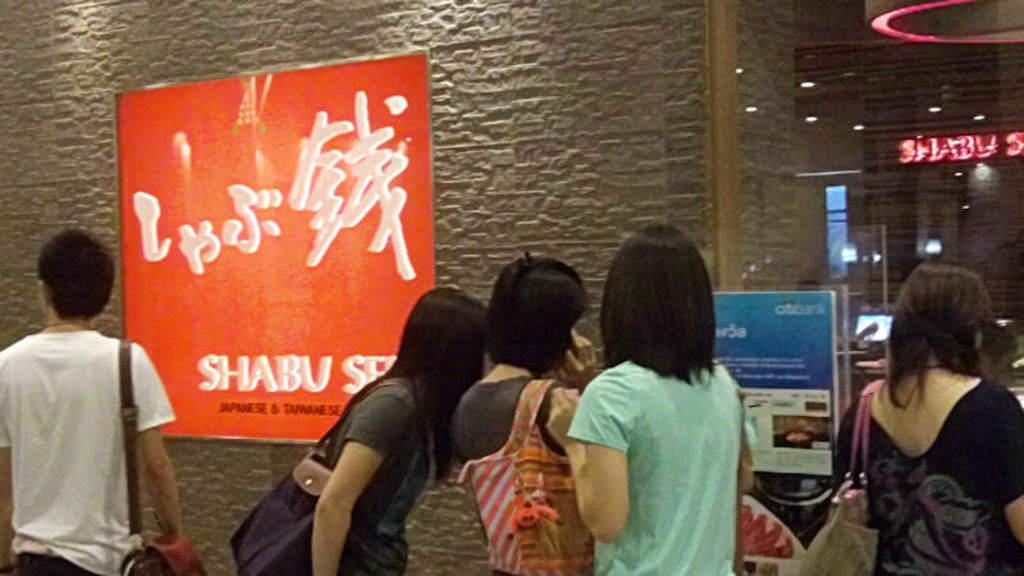How many people are present in the image? There are many people in the image. What are some people wearing in the image? Some people are wearing bags in the image. What can be seen in the background of the image? There is a wall with a poster in the background. What is written on the poster? Something is written on the poster. What type of wall is present in the image? There is a glass wall in the image. Where is another poster located in the image? There is a poster near the glass wall. How many carriages are visible in the image? There are no carriages present in the image. What type of women are depicted on the poster near the glass wall? There is no mention of women or any specific depiction on the poster near the glass wall in the provided facts. 